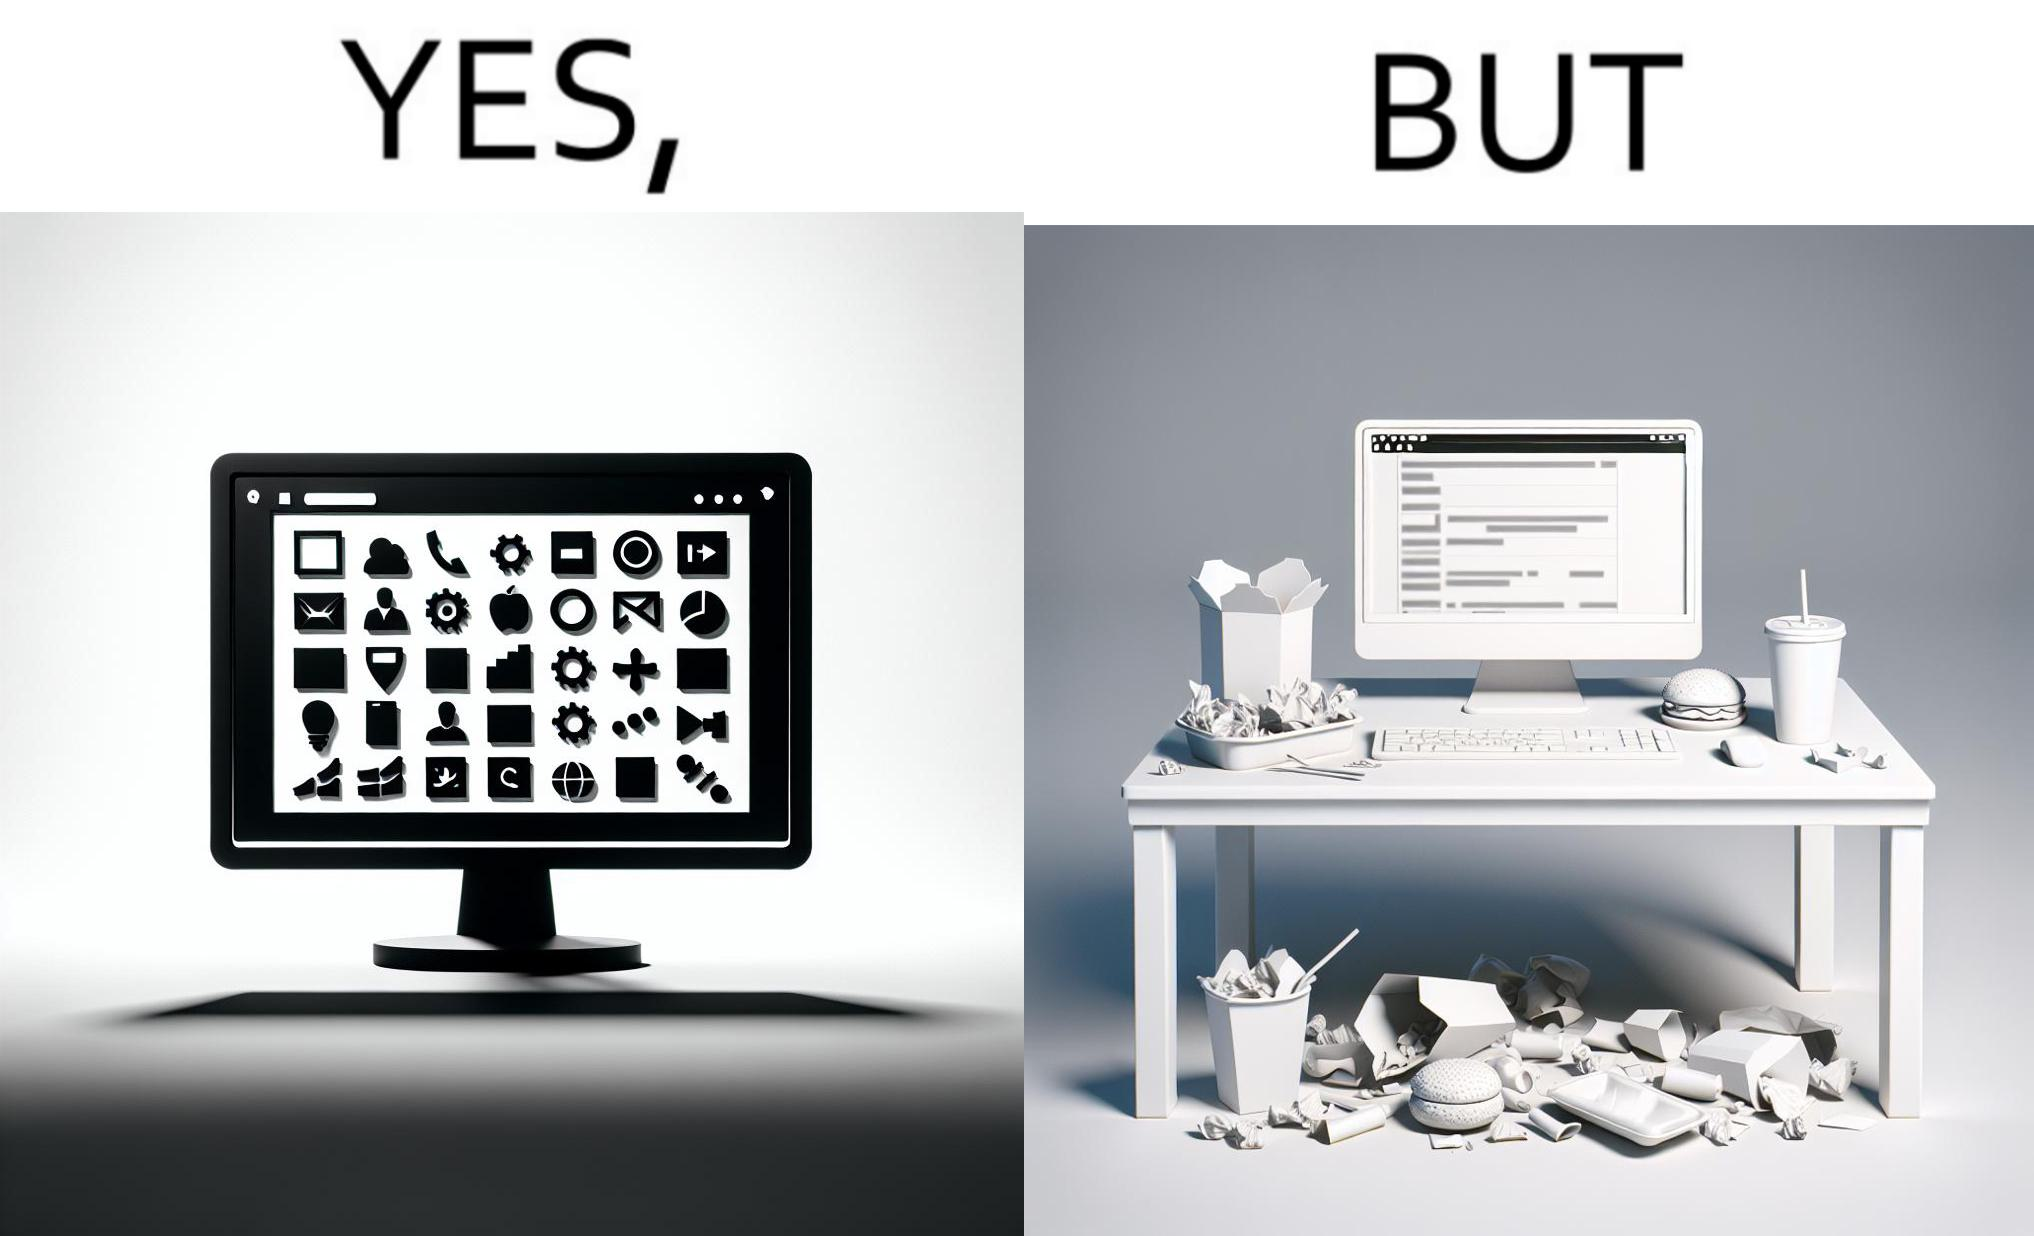Is this a satirical image? Yes, this image is satirical. 